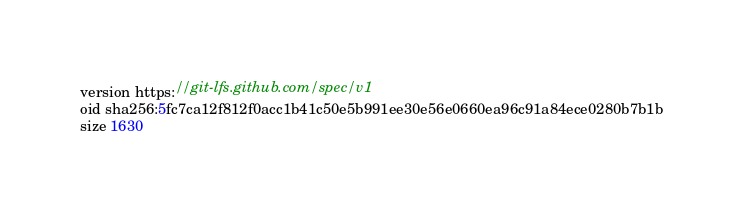<code> <loc_0><loc_0><loc_500><loc_500><_JavaScript_>version https://git-lfs.github.com/spec/v1
oid sha256:5fc7ca12f812f0acc1b41c50e5b991ee30e56e0660ea96c91a84ece0280b7b1b
size 1630
</code> 